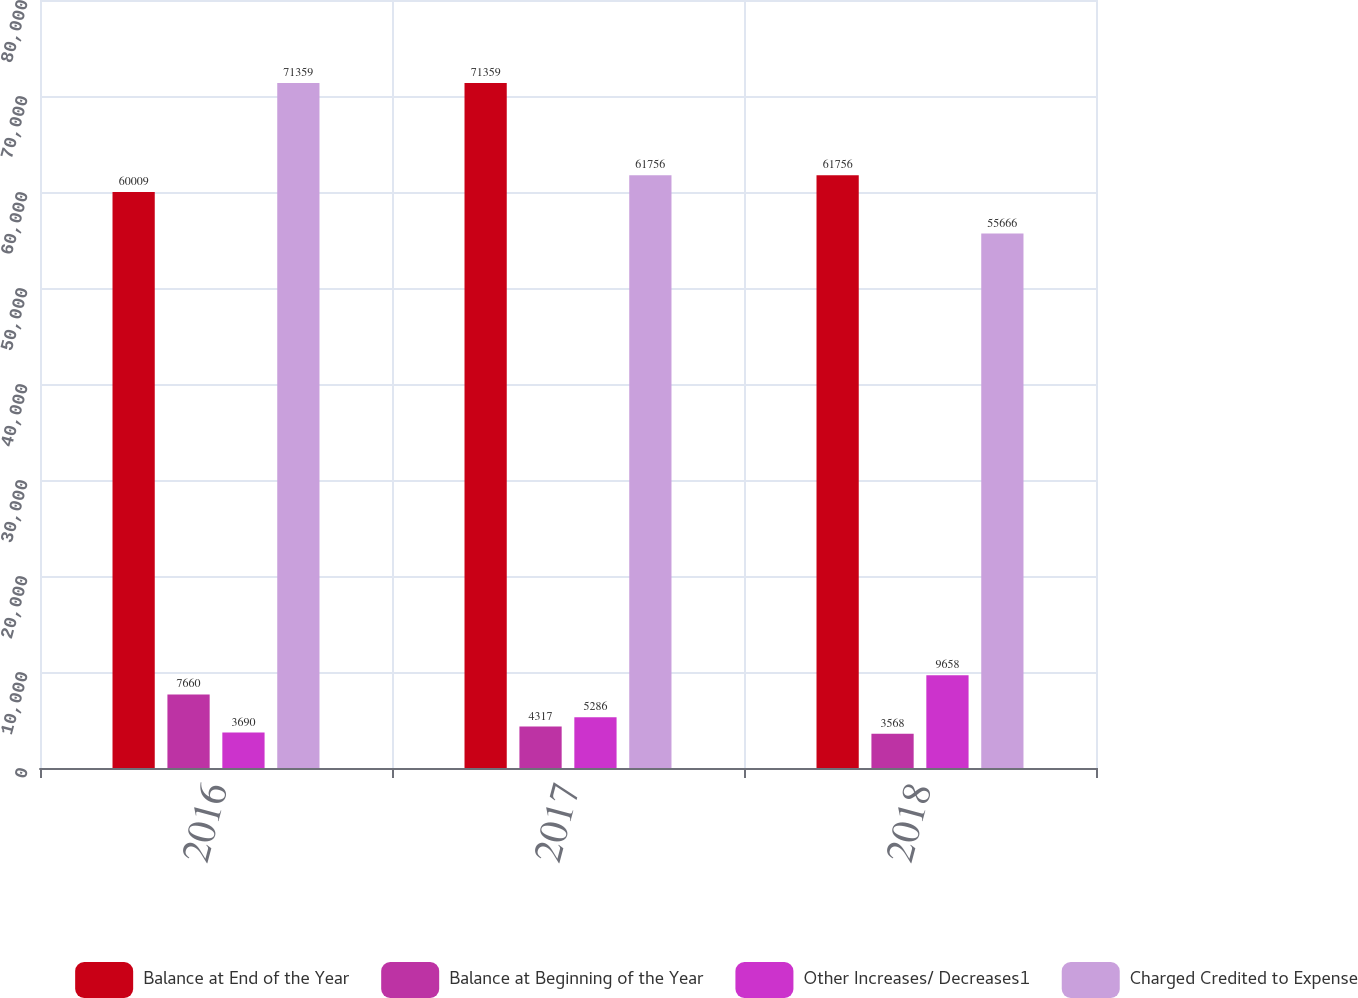Convert chart to OTSL. <chart><loc_0><loc_0><loc_500><loc_500><stacked_bar_chart><ecel><fcel>2016<fcel>2017<fcel>2018<nl><fcel>Balance at End of the Year<fcel>60009<fcel>71359<fcel>61756<nl><fcel>Balance at Beginning of the Year<fcel>7660<fcel>4317<fcel>3568<nl><fcel>Other Increases/ Decreases1<fcel>3690<fcel>5286<fcel>9658<nl><fcel>Charged Credited to Expense<fcel>71359<fcel>61756<fcel>55666<nl></chart> 